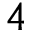Convert formula to latex. <formula><loc_0><loc_0><loc_500><loc_500>4</formula> 